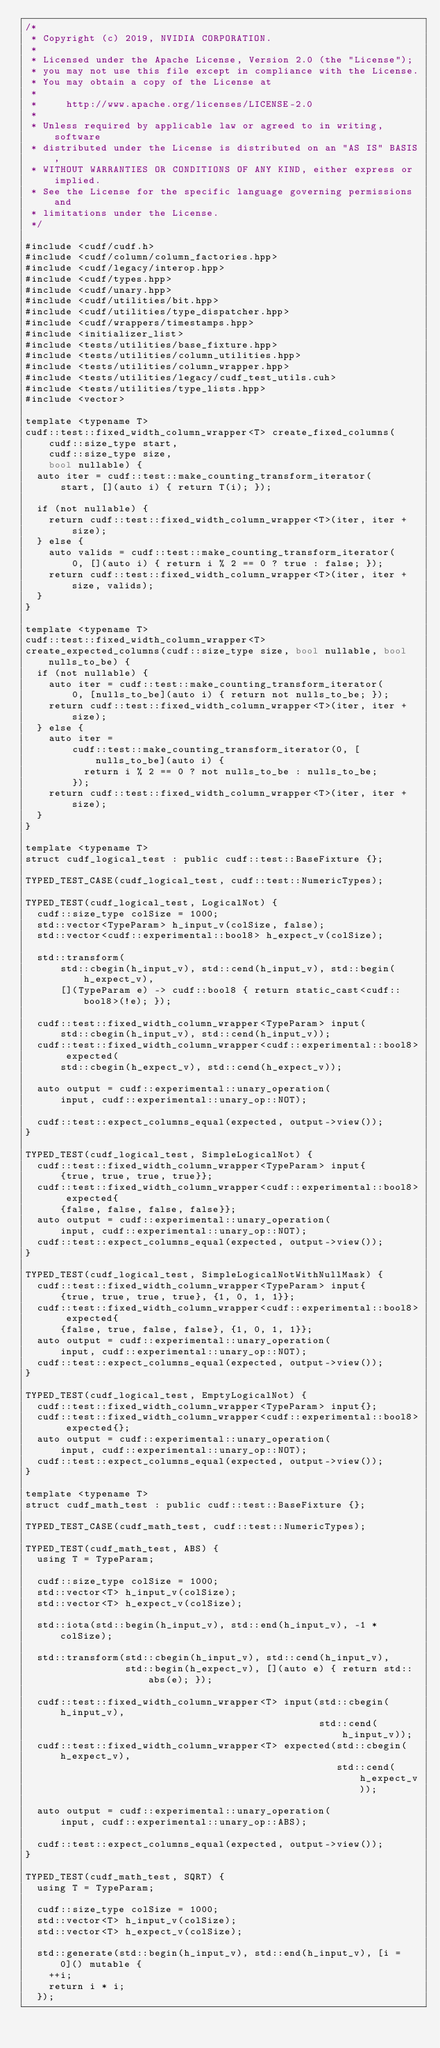<code> <loc_0><loc_0><loc_500><loc_500><_Cuda_>/*
 * Copyright (c) 2019, NVIDIA CORPORATION.
 *
 * Licensed under the Apache License, Version 2.0 (the "License");
 * you may not use this file except in compliance with the License.
 * You may obtain a copy of the License at
 *
 *     http://www.apache.org/licenses/LICENSE-2.0
 *
 * Unless required by applicable law or agreed to in writing, software
 * distributed under the License is distributed on an "AS IS" BASIS,
 * WITHOUT WARRANTIES OR CONDITIONS OF ANY KIND, either express or implied.
 * See the License for the specific language governing permissions and
 * limitations under the License.
 */

#include <cudf/cudf.h>
#include <cudf/column/column_factories.hpp>
#include <cudf/legacy/interop.hpp>
#include <cudf/types.hpp>
#include <cudf/unary.hpp>
#include <cudf/utilities/bit.hpp>
#include <cudf/utilities/type_dispatcher.hpp>
#include <cudf/wrappers/timestamps.hpp>
#include <initializer_list>
#include <tests/utilities/base_fixture.hpp>
#include <tests/utilities/column_utilities.hpp>
#include <tests/utilities/column_wrapper.hpp>
#include <tests/utilities/legacy/cudf_test_utils.cuh>
#include <tests/utilities/type_lists.hpp>
#include <vector>

template <typename T>
cudf::test::fixed_width_column_wrapper<T> create_fixed_columns(
    cudf::size_type start,
    cudf::size_type size,
    bool nullable) {
  auto iter = cudf::test::make_counting_transform_iterator(
      start, [](auto i) { return T(i); });

  if (not nullable) {
    return cudf::test::fixed_width_column_wrapper<T>(iter, iter + size);
  } else {
    auto valids = cudf::test::make_counting_transform_iterator(
        0, [](auto i) { return i % 2 == 0 ? true : false; });
    return cudf::test::fixed_width_column_wrapper<T>(iter, iter + size, valids);
  }
}

template <typename T>
cudf::test::fixed_width_column_wrapper<T>
create_expected_columns(cudf::size_type size, bool nullable, bool nulls_to_be) {
  if (not nullable) {
    auto iter = cudf::test::make_counting_transform_iterator(
        0, [nulls_to_be](auto i) { return not nulls_to_be; });
    return cudf::test::fixed_width_column_wrapper<T>(iter, iter + size);
  } else {
    auto iter =
        cudf::test::make_counting_transform_iterator(0, [nulls_to_be](auto i) {
          return i % 2 == 0 ? not nulls_to_be : nulls_to_be;
        });
    return cudf::test::fixed_width_column_wrapper<T>(iter, iter + size);
  }
}

template <typename T>
struct cudf_logical_test : public cudf::test::BaseFixture {};

TYPED_TEST_CASE(cudf_logical_test, cudf::test::NumericTypes);

TYPED_TEST(cudf_logical_test, LogicalNot) {
  cudf::size_type colSize = 1000;
  std::vector<TypeParam> h_input_v(colSize, false);
  std::vector<cudf::experimental::bool8> h_expect_v(colSize);

  std::transform(
      std::cbegin(h_input_v), std::cend(h_input_v), std::begin(h_expect_v),
      [](TypeParam e) -> cudf::bool8 { return static_cast<cudf::bool8>(!e); });

  cudf::test::fixed_width_column_wrapper<TypeParam> input(
      std::cbegin(h_input_v), std::cend(h_input_v));
  cudf::test::fixed_width_column_wrapper<cudf::experimental::bool8> expected(
      std::cbegin(h_expect_v), std::cend(h_expect_v));

  auto output = cudf::experimental::unary_operation(
      input, cudf::experimental::unary_op::NOT);

  cudf::test::expect_columns_equal(expected, output->view());
}

TYPED_TEST(cudf_logical_test, SimpleLogicalNot) {
  cudf::test::fixed_width_column_wrapper<TypeParam> input{
      {true, true, true, true}};
  cudf::test::fixed_width_column_wrapper<cudf::experimental::bool8> expected{
      {false, false, false, false}};
  auto output = cudf::experimental::unary_operation(
      input, cudf::experimental::unary_op::NOT);
  cudf::test::expect_columns_equal(expected, output->view());
}

TYPED_TEST(cudf_logical_test, SimpleLogicalNotWithNullMask) {
  cudf::test::fixed_width_column_wrapper<TypeParam> input{
      {true, true, true, true}, {1, 0, 1, 1}};
  cudf::test::fixed_width_column_wrapper<cudf::experimental::bool8> expected{
      {false, true, false, false}, {1, 0, 1, 1}};
  auto output = cudf::experimental::unary_operation(
      input, cudf::experimental::unary_op::NOT);
  cudf::test::expect_columns_equal(expected, output->view());
}

TYPED_TEST(cudf_logical_test, EmptyLogicalNot) {
  cudf::test::fixed_width_column_wrapper<TypeParam> input{};
  cudf::test::fixed_width_column_wrapper<cudf::experimental::bool8> expected{};
  auto output = cudf::experimental::unary_operation(
      input, cudf::experimental::unary_op::NOT);
  cudf::test::expect_columns_equal(expected, output->view());
}

template <typename T>
struct cudf_math_test : public cudf::test::BaseFixture {};

TYPED_TEST_CASE(cudf_math_test, cudf::test::NumericTypes);

TYPED_TEST(cudf_math_test, ABS) {
  using T = TypeParam;

  cudf::size_type colSize = 1000;
  std::vector<T> h_input_v(colSize);
  std::vector<T> h_expect_v(colSize);

  std::iota(std::begin(h_input_v), std::end(h_input_v), -1 * colSize);

  std::transform(std::cbegin(h_input_v), std::cend(h_input_v),
                 std::begin(h_expect_v), [](auto e) { return std::abs(e); });

  cudf::test::fixed_width_column_wrapper<T> input(std::cbegin(h_input_v),
                                                  std::cend(h_input_v));
  cudf::test::fixed_width_column_wrapper<T> expected(std::cbegin(h_expect_v),
                                                     std::cend(h_expect_v));

  auto output = cudf::experimental::unary_operation(
      input, cudf::experimental::unary_op::ABS);

  cudf::test::expect_columns_equal(expected, output->view());
}

TYPED_TEST(cudf_math_test, SQRT) {
  using T = TypeParam;

  cudf::size_type colSize = 1000;
  std::vector<T> h_input_v(colSize);
  std::vector<T> h_expect_v(colSize);

  std::generate(std::begin(h_input_v), std::end(h_input_v), [i = 0]() mutable {
    ++i;
    return i * i;
  });
</code> 